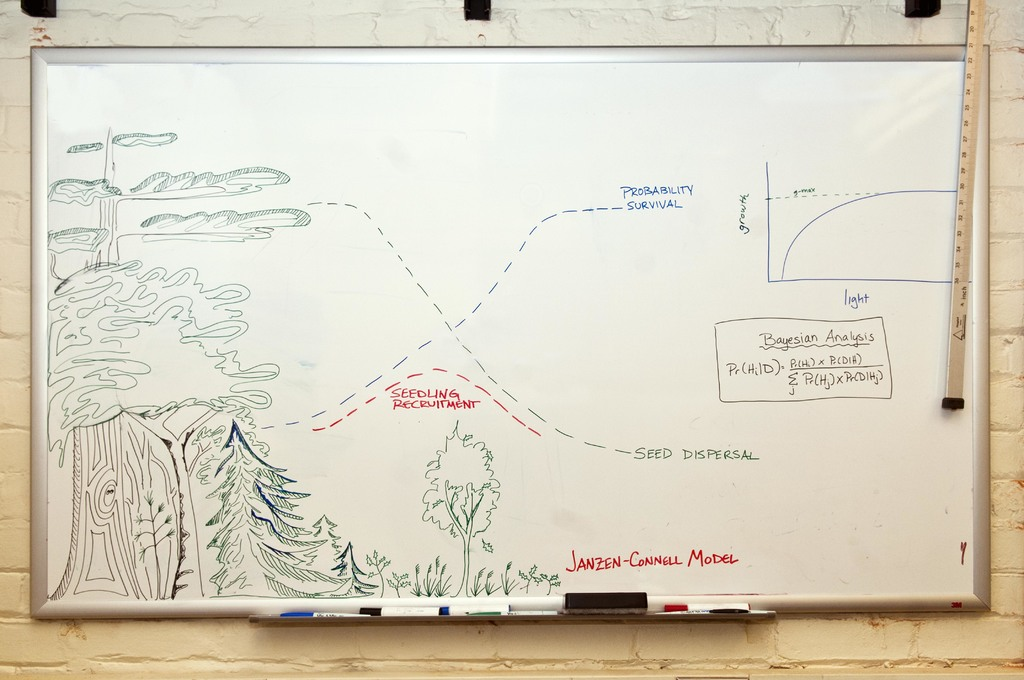Can you explain the significance of the distance from the parent tree in this model? The distance from the parent tree is crucial in the Janzen-Connell model because it influences several survival factors for seedlings. Seedlings that are closer to the parent tree face higher predation rates and competition for resources, which often results in lower survival rates. Conversely, seedlings that disperse further away are less likely to encounter these negative factors, potentially increasing their survival likelihood. This spatial relationship directly impacts biodiversity, as it helps maintain a balance in species populations and prevents any one species from dominating an area due to the natural thinning of seedlings close to their parent. 